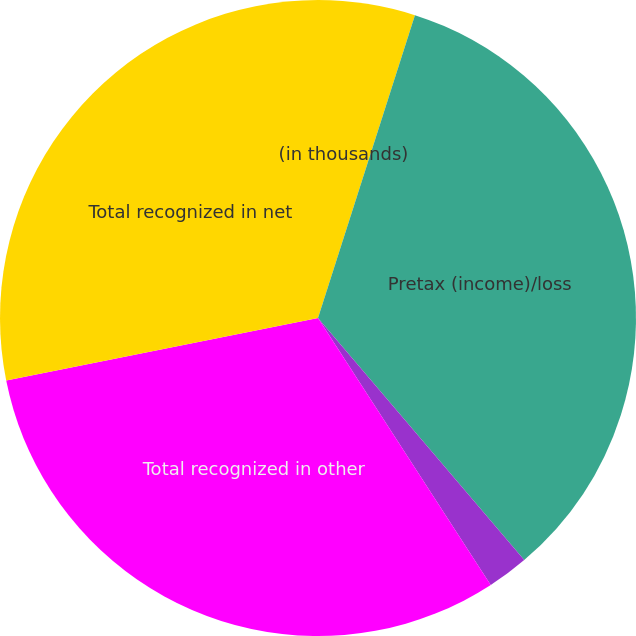<chart> <loc_0><loc_0><loc_500><loc_500><pie_chart><fcel>(in thousands)<fcel>Pretax (income)/loss<fcel>Amortization of net loss<fcel>Total recognized in other<fcel>Total recognized in net<nl><fcel>4.93%<fcel>33.84%<fcel>2.09%<fcel>30.99%<fcel>28.15%<nl></chart> 